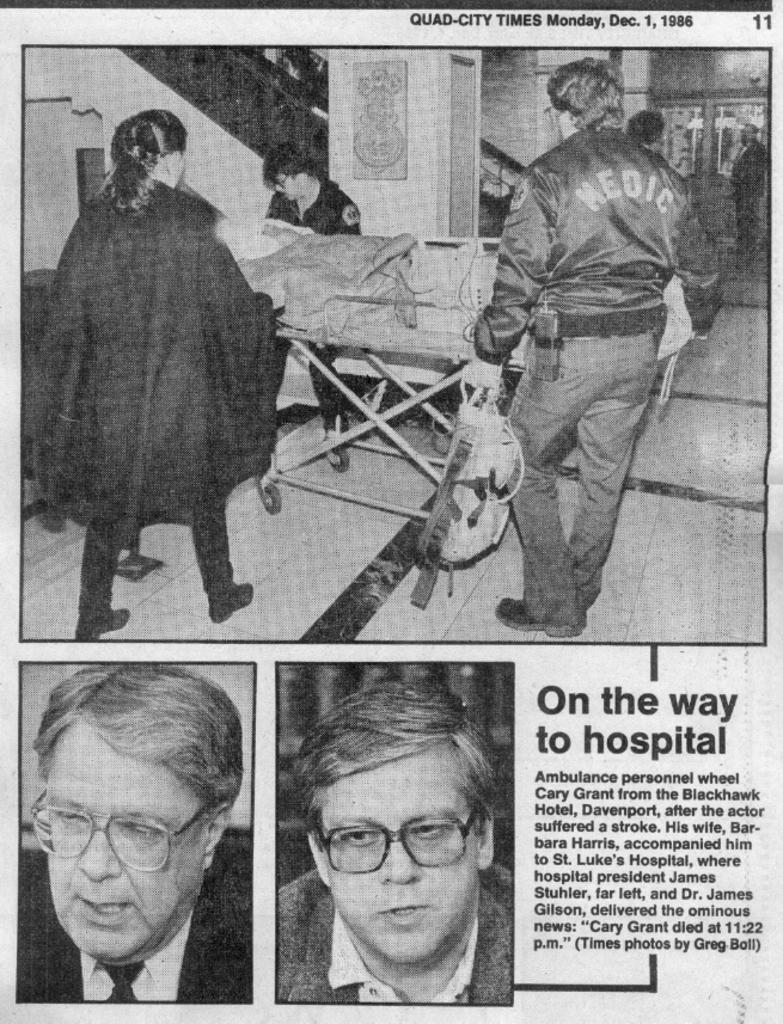<image>
Write a terse but informative summary of the picture. an old newspaper article from the Quad-City Times Dec 1, 1986 